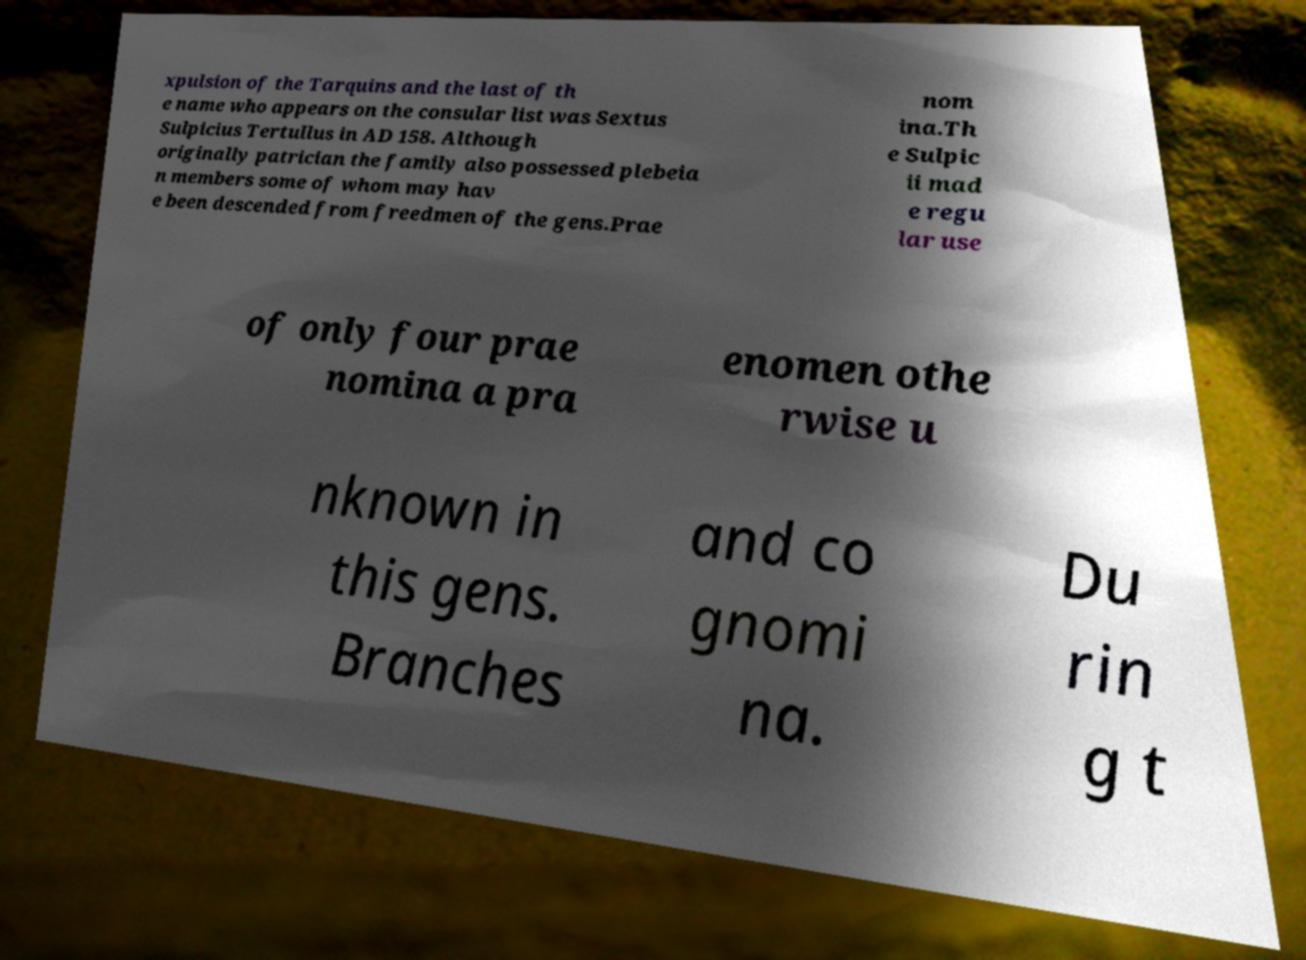For documentation purposes, I need the text within this image transcribed. Could you provide that? xpulsion of the Tarquins and the last of th e name who appears on the consular list was Sextus Sulpicius Tertullus in AD 158. Although originally patrician the family also possessed plebeia n members some of whom may hav e been descended from freedmen of the gens.Prae nom ina.Th e Sulpic ii mad e regu lar use of only four prae nomina a pra enomen othe rwise u nknown in this gens. Branches and co gnomi na. Du rin g t 